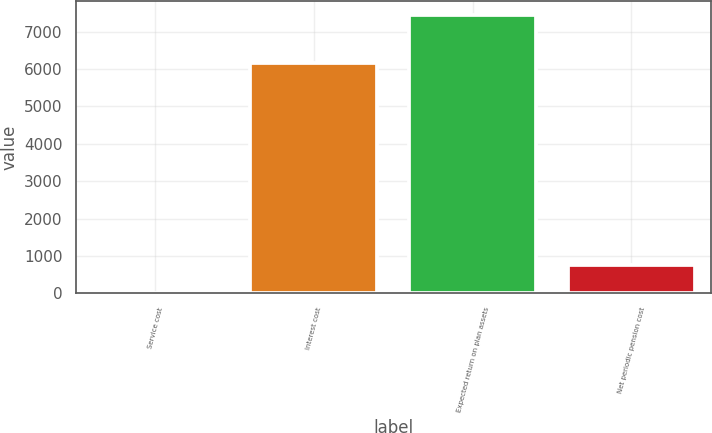<chart> <loc_0><loc_0><loc_500><loc_500><bar_chart><fcel>Service cost<fcel>Interest cost<fcel>Expected return on plan assets<fcel>Net periodic pension cost<nl><fcel>7<fcel>6166<fcel>7443<fcel>750.6<nl></chart> 